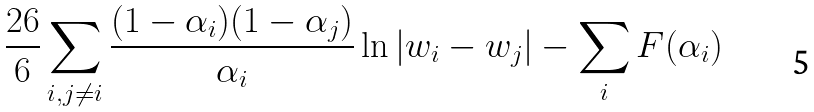Convert formula to latex. <formula><loc_0><loc_0><loc_500><loc_500>\frac { 2 6 } { 6 } \sum _ { i , j \neq i } \frac { ( 1 - \alpha _ { i } ) ( 1 - \alpha _ { j } ) } { \alpha _ { i } } \ln | w _ { i } - w _ { j } | - \sum _ { i } F ( \alpha _ { i } )</formula> 